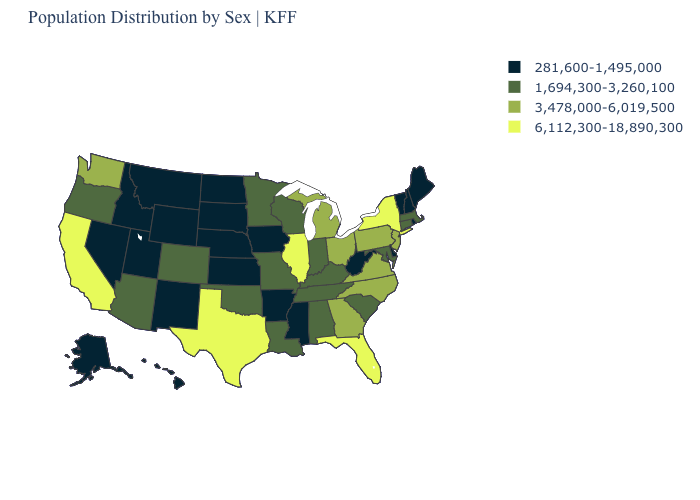What is the value of Illinois?
Quick response, please. 6,112,300-18,890,300. Name the states that have a value in the range 1,694,300-3,260,100?
Give a very brief answer. Alabama, Arizona, Colorado, Connecticut, Indiana, Kentucky, Louisiana, Maryland, Massachusetts, Minnesota, Missouri, Oklahoma, Oregon, South Carolina, Tennessee, Wisconsin. What is the value of Minnesota?
Be succinct. 1,694,300-3,260,100. What is the value of Arizona?
Answer briefly. 1,694,300-3,260,100. Does Wyoming have the same value as Nebraska?
Be succinct. Yes. Does Kentucky have the same value as Vermont?
Short answer required. No. Does Oregon have the lowest value in the West?
Write a very short answer. No. Does Michigan have a higher value than Texas?
Keep it brief. No. Name the states that have a value in the range 281,600-1,495,000?
Be succinct. Alaska, Arkansas, Delaware, Hawaii, Idaho, Iowa, Kansas, Maine, Mississippi, Montana, Nebraska, Nevada, New Hampshire, New Mexico, North Dakota, Rhode Island, South Dakota, Utah, Vermont, West Virginia, Wyoming. Name the states that have a value in the range 281,600-1,495,000?
Quick response, please. Alaska, Arkansas, Delaware, Hawaii, Idaho, Iowa, Kansas, Maine, Mississippi, Montana, Nebraska, Nevada, New Hampshire, New Mexico, North Dakota, Rhode Island, South Dakota, Utah, Vermont, West Virginia, Wyoming. Does the map have missing data?
Concise answer only. No. Among the states that border South Carolina , which have the highest value?
Short answer required. Georgia, North Carolina. Which states have the highest value in the USA?
Concise answer only. California, Florida, Illinois, New York, Texas. What is the value of Delaware?
Be succinct. 281,600-1,495,000. Which states have the lowest value in the Northeast?
Write a very short answer. Maine, New Hampshire, Rhode Island, Vermont. 